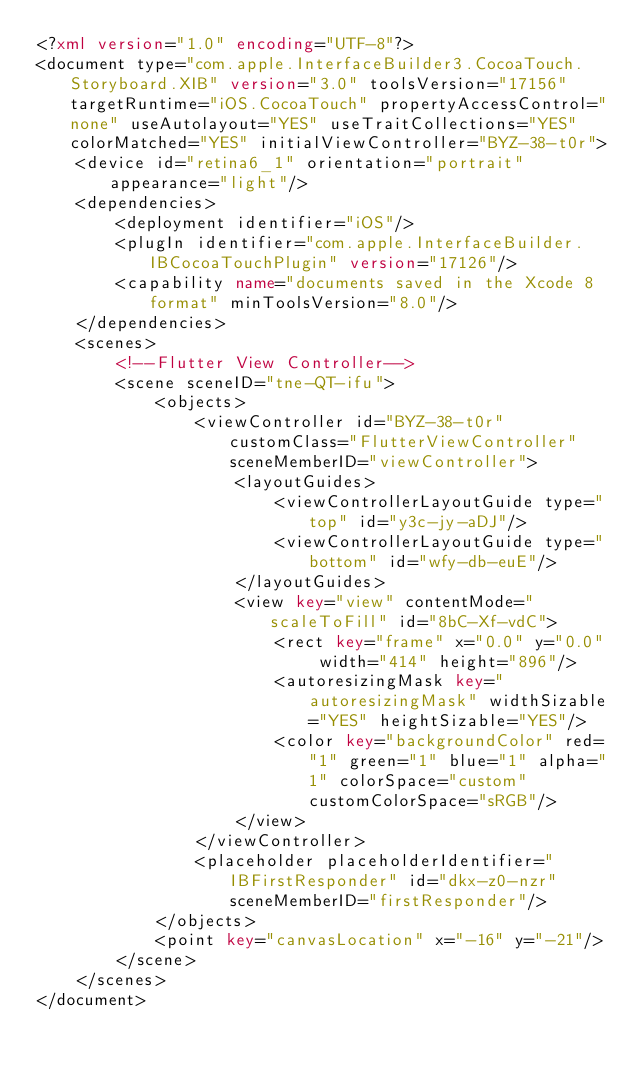<code> <loc_0><loc_0><loc_500><loc_500><_XML_><?xml version="1.0" encoding="UTF-8"?>
<document type="com.apple.InterfaceBuilder3.CocoaTouch.Storyboard.XIB" version="3.0" toolsVersion="17156" targetRuntime="iOS.CocoaTouch" propertyAccessControl="none" useAutolayout="YES" useTraitCollections="YES" colorMatched="YES" initialViewController="BYZ-38-t0r">
    <device id="retina6_1" orientation="portrait" appearance="light"/>
    <dependencies>
        <deployment identifier="iOS"/>
        <plugIn identifier="com.apple.InterfaceBuilder.IBCocoaTouchPlugin" version="17126"/>
        <capability name="documents saved in the Xcode 8 format" minToolsVersion="8.0"/>
    </dependencies>
    <scenes>
        <!--Flutter View Controller-->
        <scene sceneID="tne-QT-ifu">
            <objects>
                <viewController id="BYZ-38-t0r" customClass="FlutterViewController" sceneMemberID="viewController">
                    <layoutGuides>
                        <viewControllerLayoutGuide type="top" id="y3c-jy-aDJ"/>
                        <viewControllerLayoutGuide type="bottom" id="wfy-db-euE"/>
                    </layoutGuides>
                    <view key="view" contentMode="scaleToFill" id="8bC-Xf-vdC">
                        <rect key="frame" x="0.0" y="0.0" width="414" height="896"/>
                        <autoresizingMask key="autoresizingMask" widthSizable="YES" heightSizable="YES"/>
                        <color key="backgroundColor" red="1" green="1" blue="1" alpha="1" colorSpace="custom" customColorSpace="sRGB"/>
                    </view>
                </viewController>
                <placeholder placeholderIdentifier="IBFirstResponder" id="dkx-z0-nzr" sceneMemberID="firstResponder"/>
            </objects>
            <point key="canvasLocation" x="-16" y="-21"/>
        </scene>
    </scenes>
</document>
</code> 